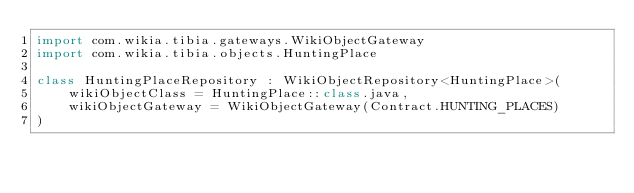<code> <loc_0><loc_0><loc_500><loc_500><_Kotlin_>import com.wikia.tibia.gateways.WikiObjectGateway
import com.wikia.tibia.objects.HuntingPlace

class HuntingPlaceRepository : WikiObjectRepository<HuntingPlace>(
    wikiObjectClass = HuntingPlace::class.java,
    wikiObjectGateway = WikiObjectGateway(Contract.HUNTING_PLACES)
)
</code> 